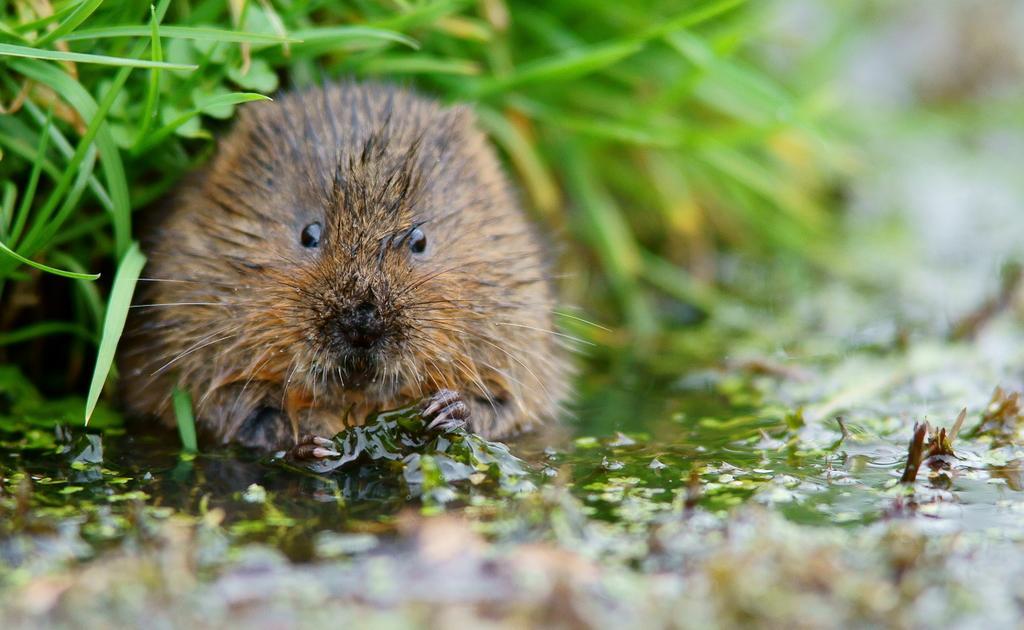Can you describe this image briefly? In the picture we can see a rat near the water with some water plants in it and in the background we can see a grass plant. 